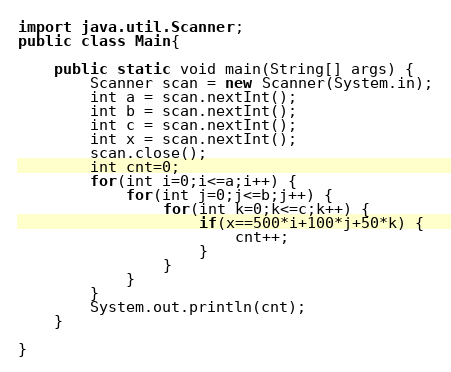Convert code to text. <code><loc_0><loc_0><loc_500><loc_500><_Java_>import java.util.Scanner;
public class Main{

	public static void main(String[] args) {
		Scanner scan = new Scanner(System.in);
	    int a = scan.nextInt();
	    int b = scan.nextInt();
	    int c = scan.nextInt();
	    int x = scan.nextInt();
	    scan.close();
	    int cnt=0;
	    for(int i=0;i<=a;i++) {
	    	for(int j=0;j<=b;j++) {
	    		for(int k=0;k<=c;k++) {
			    	if(x==500*i+100*j+50*k) {
			    		cnt++;
			    	}
	    		}
		    }
	    }
	    System.out.println(cnt);
	}

}</code> 